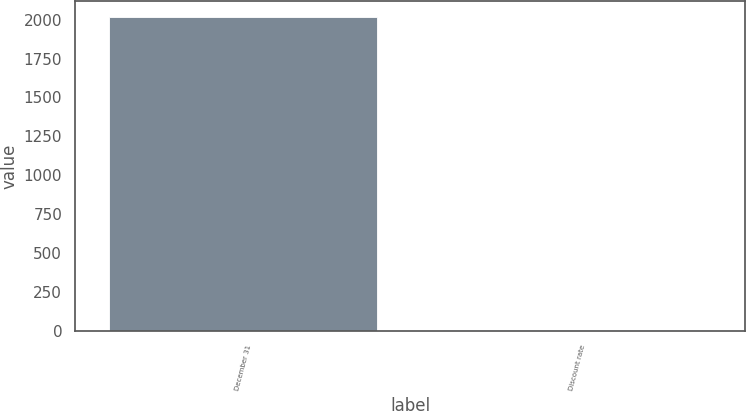Convert chart to OTSL. <chart><loc_0><loc_0><loc_500><loc_500><bar_chart><fcel>December 31<fcel>Discount rate<nl><fcel>2017<fcel>3.5<nl></chart> 